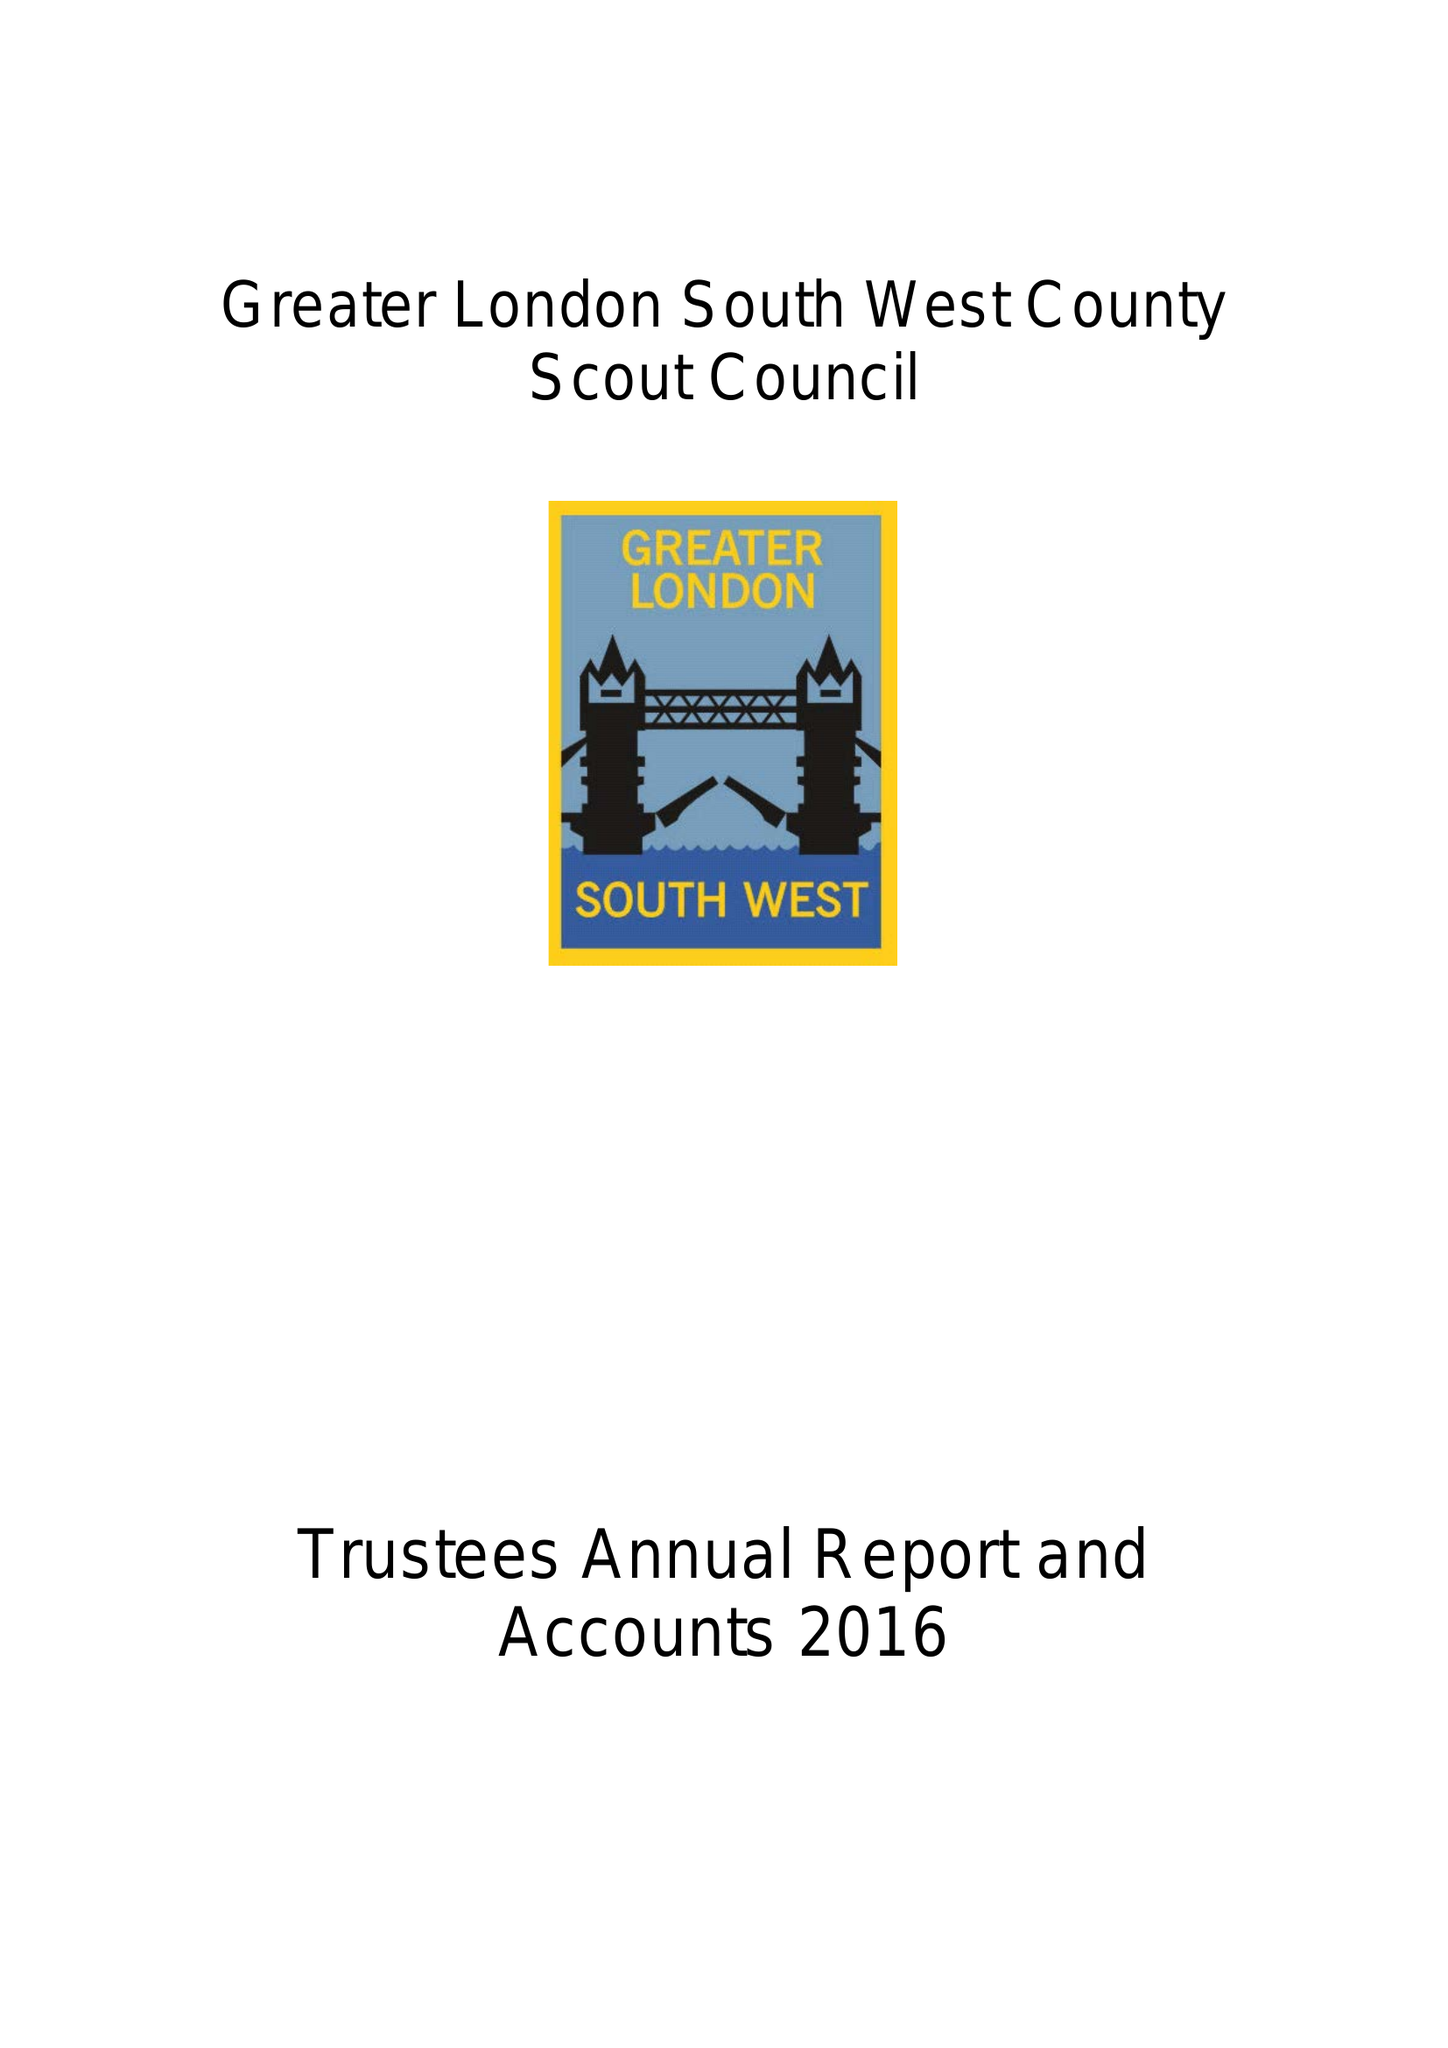What is the value for the charity_name?
Answer the question using a single word or phrase. Greater London, South West County Scout Council 